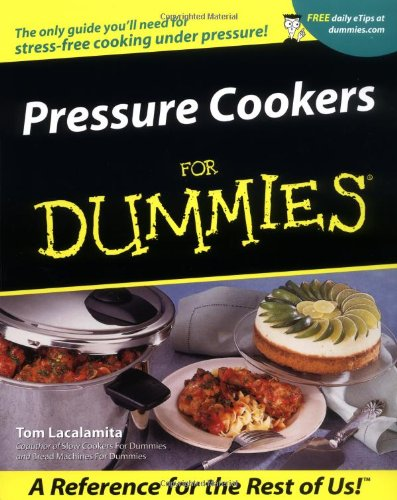What is the title of this book? The title of the book displayed in the image is 'Pressure Cookers For Dummies.' It's a practical guide for those new to using pressure cookers. 